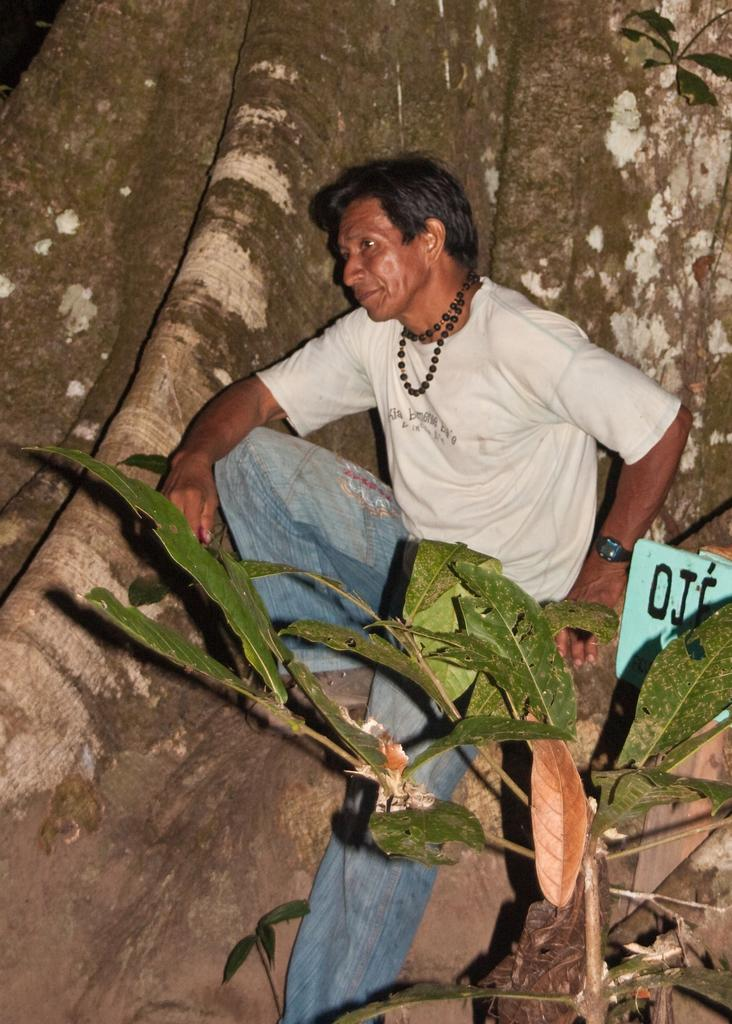Who or what is present in the image? There is a person in the image. What is the person wearing? The person is wearing a white t-shirt. Where is the person located in the image? The person is on a tree. Can you describe the tree in the image? There is a tree with green leaves in the image. What degree does the person in the image have? There is no information about the person's degree in the image. What type of silver object can be seen in the image? There is no silver object present in the image. 